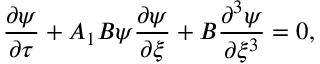<formula> <loc_0><loc_0><loc_500><loc_500>\frac { \partial \psi } { \partial \tau } + A _ { 1 } B \psi \frac { \partial \psi } { \partial \xi } + B \frac { \partial ^ { 3 } \psi } { \partial \xi ^ { 3 } } = 0 ,</formula> 